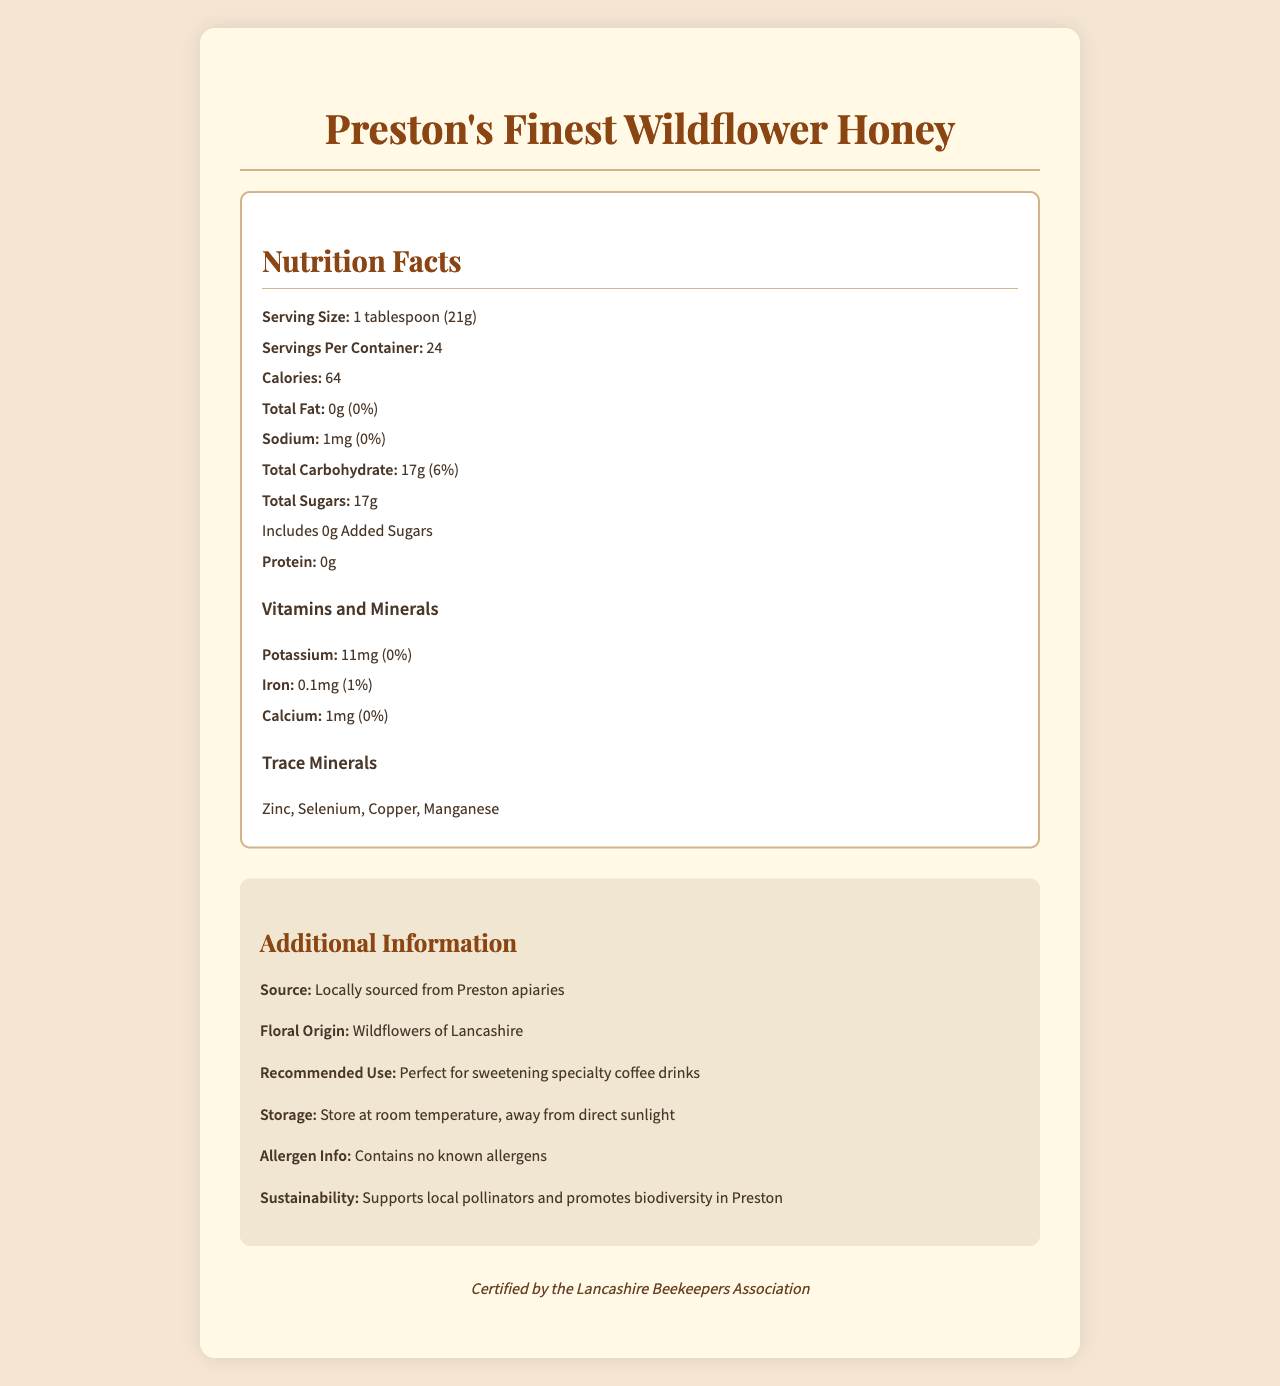what is the serving size of Preston's Finest Wildflower Honey? The serving size is clearly stated in the nutrition facts label at the beginning: "Serving Size: 1 tablespoon (21g)".
Answer: 1 tablespoon (21g) how many calories are in one serving of this honey? The label specifies: "Calories: 64".
Answer: 64 calories what is the total carbohydrate amount per serving? The label lists: "Total Carbohydrate: 17g".
Answer: 17g how much potassium is in one serving of this honey? Under "Vitamins and Minerals", it shows: "Potassium: 11mg".
Answer: 11mg does this honey contain any added sugars? The document explicitly states: "Includes 0g Added Sugars".
Answer: No which of the following trace minerals is *not* listed on the label? A. Zinc B. Magnesium C. Selenium D. Copper The label lists Zinc, Selenium, Copper, and Manganese as trace minerals, but not Magnesium.
Answer: B. Magnesium what is the recommended use for this honey? A. Cooking B. Baking C. Sweetening specialty coffee drinks D. Salad dressing The "Additional Information" section mentions: "Recommended Use: Perfect for sweetening specialty coffee drinks".
Answer: C. Sweetening specialty coffee drinks is there any iron in this honey? The label lists iron under "Vitamins and Minerals": "Iron: 0.1mg".
Answer: Yes does this honey support local pollinators and biodiversity in Preston? The sustainability section states: "Supports local pollinators and promotes biodiversity in Preston".
Answer: Yes summarize the main idea of this document. The document covers comprehensive details about the product, nutrition information, sources, recommended use, and additional benefits related to sustainability and certification.
Answer: The document provides detailed nutrition facts for "Preston's Finest Wildflower Honey", highlighting natural sugars and trace minerals, with information about serving size, calories, vitamins, and minerals. It emphasizes the local sourcing from Preston apiaries, its sustainability in supporting local pollinators, and its certification by the Lancashire Beekeepers Association. This honey is recommended for sweetening specialty coffee drinks and contains no known allergens. what is the floral origin of the honey? The "Additional Information" section states: "Floral Origin: Wildflowers of Lancashire".
Answer: Wildflowers of Lancashire where is this honey sourced from? The source is specified in the additional information: "Source: Locally sourced from Preston apiaries".
Answer: Preston apiaries what is the daily value percentage of total fat in this honey? The label specifies: "Total Fat: 0g (0%)".
Answer: 0% how many servings are there per container of this honey? The nutrition facts label mentions: "Servings Per Container: 24".
Answer: 24 does this honey contain any allergens? The allergen info states: "Contains no known allergens".
Answer: No is the daily value of calcium in this honey greater than 1%? The label shows: "Calcium: 1mg (0%)".
Answer: No how is this honey certified? The certification is mentioned at the end of the document.
Answer: Certified by the Lancashire Beekeepers Association how should this honey be stored? The storage information states: "Store at room temperature, away from direct sunlight".
Answer: At room temperature, away from direct sunlight what is the total trace minerals amount in one serving? The label provides a list of trace minerals but does not specify the total amount.
Answer: Not enough information 